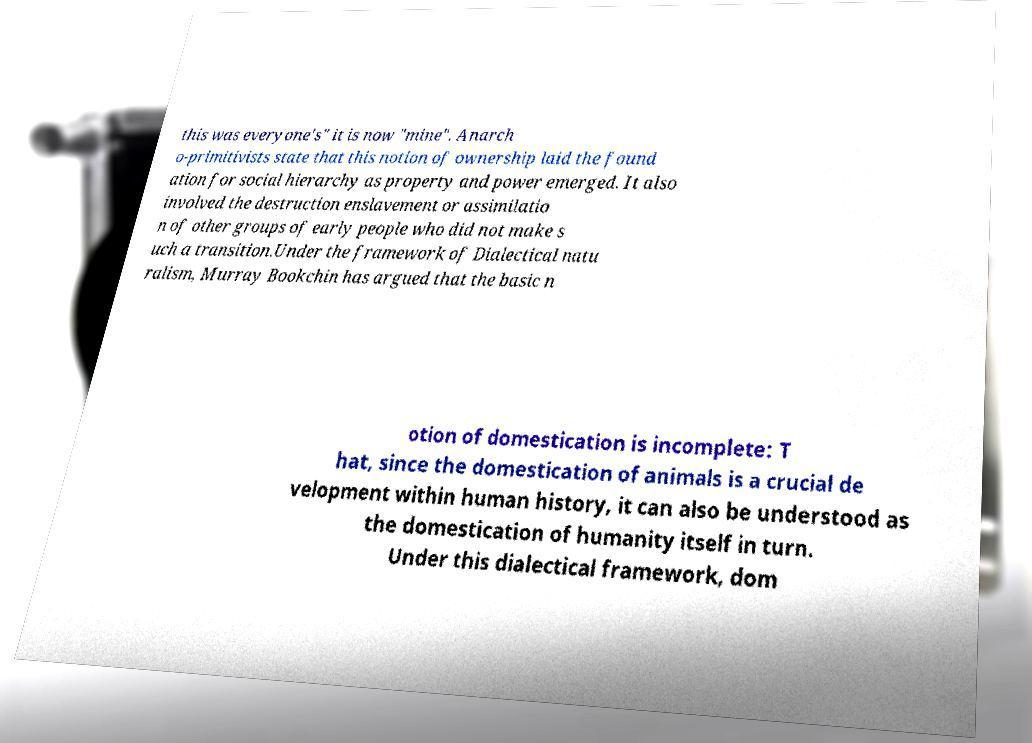There's text embedded in this image that I need extracted. Can you transcribe it verbatim? this was everyone's" it is now "mine". Anarch o-primitivists state that this notion of ownership laid the found ation for social hierarchy as property and power emerged. It also involved the destruction enslavement or assimilatio n of other groups of early people who did not make s uch a transition.Under the framework of Dialectical natu ralism, Murray Bookchin has argued that the basic n otion of domestication is incomplete: T hat, since the domestication of animals is a crucial de velopment within human history, it can also be understood as the domestication of humanity itself in turn. Under this dialectical framework, dom 